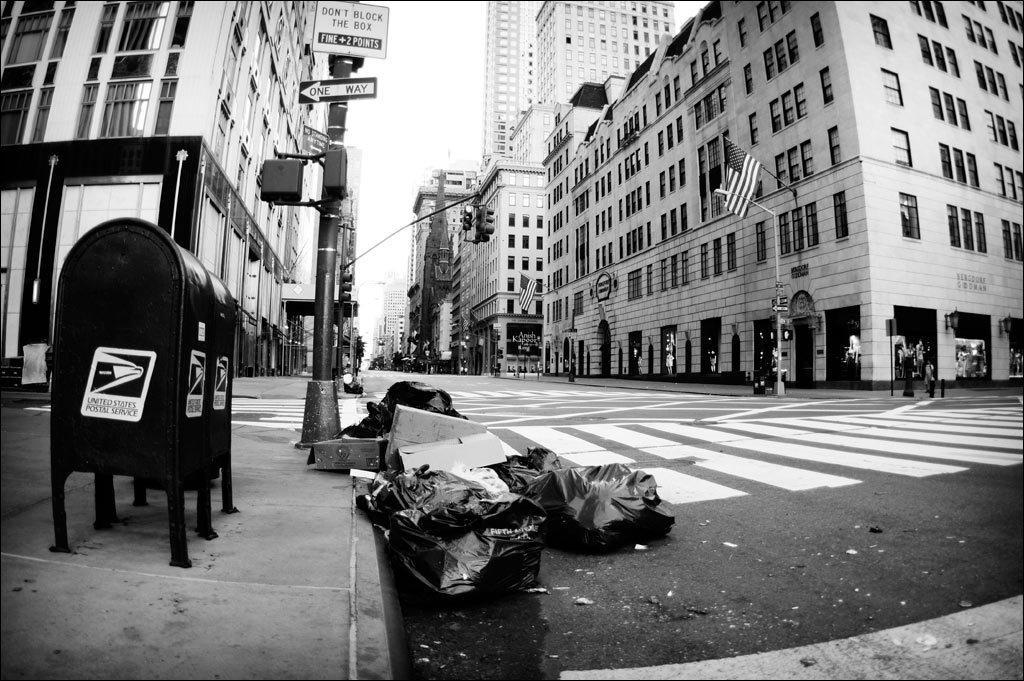In one or two sentences, can you explain what this image depicts? In this black and white image there is a road and few objects are placed on the road. On the right and left side of the image there are buildings, in front of the buildings there are a few poles with sign boards, flags and trees. In the background there is the sky. 